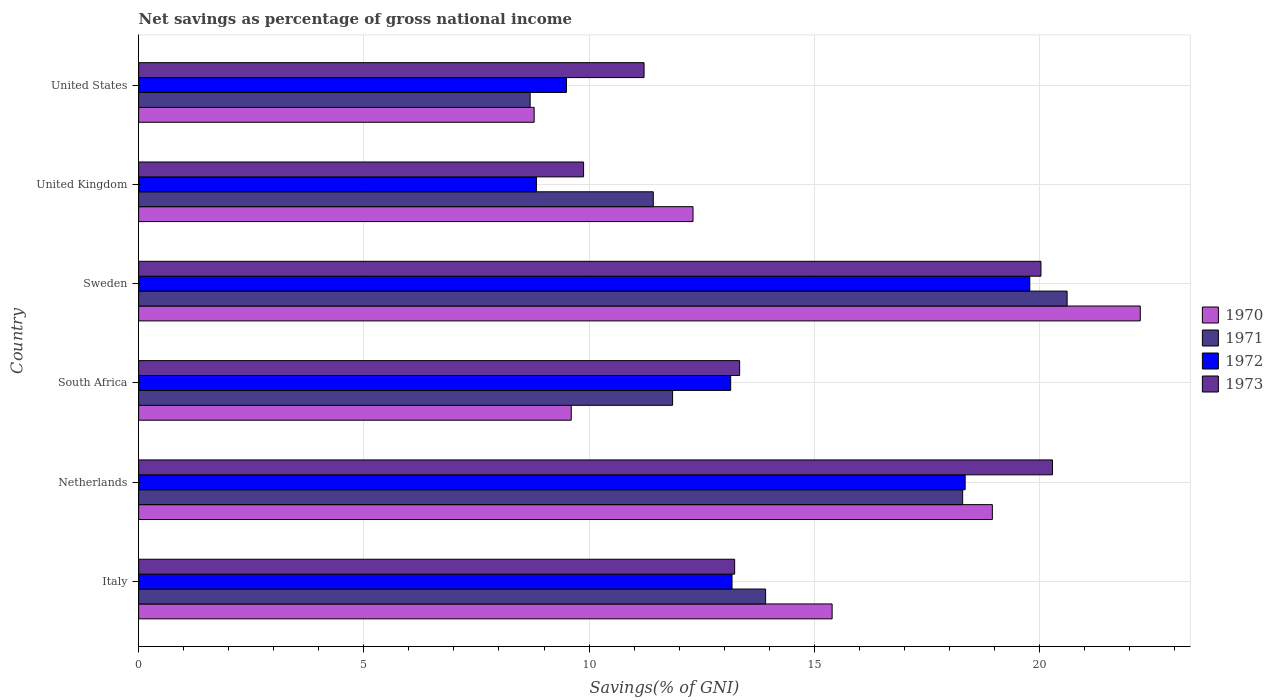How many groups of bars are there?
Your answer should be very brief. 6. Are the number of bars per tick equal to the number of legend labels?
Ensure brevity in your answer.  Yes. Are the number of bars on each tick of the Y-axis equal?
Make the answer very short. Yes. How many bars are there on the 3rd tick from the bottom?
Make the answer very short. 4. What is the total savings in 1970 in Italy?
Offer a terse response. 15.4. Across all countries, what is the maximum total savings in 1972?
Offer a terse response. 19.78. Across all countries, what is the minimum total savings in 1973?
Your answer should be compact. 9.88. In which country was the total savings in 1971 minimum?
Ensure brevity in your answer.  United States. What is the total total savings in 1973 in the graph?
Provide a short and direct response. 87.99. What is the difference between the total savings in 1970 in United Kingdom and that in United States?
Offer a very short reply. 3.53. What is the difference between the total savings in 1971 in Sweden and the total savings in 1973 in Netherlands?
Keep it short and to the point. 0.33. What is the average total savings in 1973 per country?
Offer a very short reply. 14.67. What is the difference between the total savings in 1971 and total savings in 1970 in United Kingdom?
Your answer should be very brief. -0.88. In how many countries, is the total savings in 1970 greater than 7 %?
Your response must be concise. 6. What is the ratio of the total savings in 1973 in Italy to that in Sweden?
Offer a very short reply. 0.66. What is the difference between the highest and the second highest total savings in 1971?
Your response must be concise. 2.32. What is the difference between the highest and the lowest total savings in 1970?
Offer a terse response. 13.46. Is the sum of the total savings in 1970 in Italy and United Kingdom greater than the maximum total savings in 1972 across all countries?
Offer a very short reply. Yes. Is it the case that in every country, the sum of the total savings in 1971 and total savings in 1970 is greater than the sum of total savings in 1972 and total savings in 1973?
Your answer should be very brief. No. What does the 3rd bar from the top in United Kingdom represents?
Keep it short and to the point. 1971. What does the 1st bar from the bottom in South Africa represents?
Keep it short and to the point. 1970. How many bars are there?
Keep it short and to the point. 24. What is the difference between two consecutive major ticks on the X-axis?
Provide a succinct answer. 5. Does the graph contain grids?
Keep it short and to the point. Yes. Where does the legend appear in the graph?
Your response must be concise. Center right. How many legend labels are there?
Provide a succinct answer. 4. How are the legend labels stacked?
Make the answer very short. Vertical. What is the title of the graph?
Make the answer very short. Net savings as percentage of gross national income. Does "2004" appear as one of the legend labels in the graph?
Keep it short and to the point. No. What is the label or title of the X-axis?
Provide a succinct answer. Savings(% of GNI). What is the Savings(% of GNI) of 1970 in Italy?
Your answer should be very brief. 15.4. What is the Savings(% of GNI) in 1971 in Italy?
Provide a succinct answer. 13.92. What is the Savings(% of GNI) in 1972 in Italy?
Make the answer very short. 13.17. What is the Savings(% of GNI) of 1973 in Italy?
Provide a succinct answer. 13.23. What is the Savings(% of GNI) in 1970 in Netherlands?
Your answer should be very brief. 18.95. What is the Savings(% of GNI) of 1971 in Netherlands?
Keep it short and to the point. 18.29. What is the Savings(% of GNI) in 1972 in Netherlands?
Your answer should be very brief. 18.35. What is the Savings(% of GNI) in 1973 in Netherlands?
Ensure brevity in your answer.  20.29. What is the Savings(% of GNI) in 1970 in South Africa?
Offer a terse response. 9.6. What is the Savings(% of GNI) in 1971 in South Africa?
Give a very brief answer. 11.85. What is the Savings(% of GNI) in 1972 in South Africa?
Provide a succinct answer. 13.14. What is the Savings(% of GNI) in 1973 in South Africa?
Provide a short and direct response. 13.34. What is the Savings(% of GNI) of 1970 in Sweden?
Provide a short and direct response. 22.24. What is the Savings(% of GNI) of 1971 in Sweden?
Offer a terse response. 20.61. What is the Savings(% of GNI) of 1972 in Sweden?
Your answer should be compact. 19.78. What is the Savings(% of GNI) in 1973 in Sweden?
Offer a terse response. 20.03. What is the Savings(% of GNI) of 1970 in United Kingdom?
Provide a short and direct response. 12.31. What is the Savings(% of GNI) in 1971 in United Kingdom?
Keep it short and to the point. 11.43. What is the Savings(% of GNI) in 1972 in United Kingdom?
Keep it short and to the point. 8.83. What is the Savings(% of GNI) of 1973 in United Kingdom?
Offer a very short reply. 9.88. What is the Savings(% of GNI) of 1970 in United States?
Provide a short and direct response. 8.78. What is the Savings(% of GNI) of 1971 in United States?
Offer a terse response. 8.69. What is the Savings(% of GNI) in 1972 in United States?
Your response must be concise. 9.5. What is the Savings(% of GNI) of 1973 in United States?
Provide a succinct answer. 11.22. Across all countries, what is the maximum Savings(% of GNI) of 1970?
Make the answer very short. 22.24. Across all countries, what is the maximum Savings(% of GNI) of 1971?
Provide a short and direct response. 20.61. Across all countries, what is the maximum Savings(% of GNI) in 1972?
Offer a very short reply. 19.78. Across all countries, what is the maximum Savings(% of GNI) in 1973?
Make the answer very short. 20.29. Across all countries, what is the minimum Savings(% of GNI) in 1970?
Your answer should be very brief. 8.78. Across all countries, what is the minimum Savings(% of GNI) of 1971?
Give a very brief answer. 8.69. Across all countries, what is the minimum Savings(% of GNI) in 1972?
Offer a terse response. 8.83. Across all countries, what is the minimum Savings(% of GNI) in 1973?
Ensure brevity in your answer.  9.88. What is the total Savings(% of GNI) of 1970 in the graph?
Your response must be concise. 87.28. What is the total Savings(% of GNI) of 1971 in the graph?
Offer a terse response. 84.8. What is the total Savings(% of GNI) of 1972 in the graph?
Give a very brief answer. 82.78. What is the total Savings(% of GNI) in 1973 in the graph?
Provide a succinct answer. 87.99. What is the difference between the Savings(% of GNI) in 1970 in Italy and that in Netherlands?
Ensure brevity in your answer.  -3.56. What is the difference between the Savings(% of GNI) in 1971 in Italy and that in Netherlands?
Provide a short and direct response. -4.37. What is the difference between the Savings(% of GNI) in 1972 in Italy and that in Netherlands?
Keep it short and to the point. -5.18. What is the difference between the Savings(% of GNI) of 1973 in Italy and that in Netherlands?
Keep it short and to the point. -7.06. What is the difference between the Savings(% of GNI) in 1970 in Italy and that in South Africa?
Your answer should be very brief. 5.79. What is the difference between the Savings(% of GNI) of 1971 in Italy and that in South Africa?
Make the answer very short. 2.07. What is the difference between the Savings(% of GNI) of 1972 in Italy and that in South Africa?
Give a very brief answer. 0.03. What is the difference between the Savings(% of GNI) in 1973 in Italy and that in South Africa?
Provide a succinct answer. -0.11. What is the difference between the Savings(% of GNI) in 1970 in Italy and that in Sweden?
Provide a short and direct response. -6.84. What is the difference between the Savings(% of GNI) of 1971 in Italy and that in Sweden?
Your response must be concise. -6.69. What is the difference between the Savings(% of GNI) of 1972 in Italy and that in Sweden?
Make the answer very short. -6.61. What is the difference between the Savings(% of GNI) of 1973 in Italy and that in Sweden?
Provide a succinct answer. -6.8. What is the difference between the Savings(% of GNI) of 1970 in Italy and that in United Kingdom?
Offer a very short reply. 3.09. What is the difference between the Savings(% of GNI) in 1971 in Italy and that in United Kingdom?
Offer a very short reply. 2.49. What is the difference between the Savings(% of GNI) of 1972 in Italy and that in United Kingdom?
Provide a short and direct response. 4.34. What is the difference between the Savings(% of GNI) in 1973 in Italy and that in United Kingdom?
Your answer should be very brief. 3.35. What is the difference between the Savings(% of GNI) of 1970 in Italy and that in United States?
Make the answer very short. 6.62. What is the difference between the Savings(% of GNI) of 1971 in Italy and that in United States?
Offer a very short reply. 5.23. What is the difference between the Savings(% of GNI) of 1972 in Italy and that in United States?
Provide a succinct answer. 3.68. What is the difference between the Savings(% of GNI) of 1973 in Italy and that in United States?
Keep it short and to the point. 2.01. What is the difference between the Savings(% of GNI) in 1970 in Netherlands and that in South Africa?
Make the answer very short. 9.35. What is the difference between the Savings(% of GNI) of 1971 in Netherlands and that in South Africa?
Offer a very short reply. 6.44. What is the difference between the Savings(% of GNI) in 1972 in Netherlands and that in South Africa?
Make the answer very short. 5.21. What is the difference between the Savings(% of GNI) of 1973 in Netherlands and that in South Africa?
Provide a succinct answer. 6.95. What is the difference between the Savings(% of GNI) in 1970 in Netherlands and that in Sweden?
Offer a terse response. -3.28. What is the difference between the Savings(% of GNI) in 1971 in Netherlands and that in Sweden?
Offer a very short reply. -2.32. What is the difference between the Savings(% of GNI) in 1972 in Netherlands and that in Sweden?
Offer a very short reply. -1.43. What is the difference between the Savings(% of GNI) in 1973 in Netherlands and that in Sweden?
Keep it short and to the point. 0.26. What is the difference between the Savings(% of GNI) of 1970 in Netherlands and that in United Kingdom?
Offer a terse response. 6.65. What is the difference between the Savings(% of GNI) in 1971 in Netherlands and that in United Kingdom?
Give a very brief answer. 6.87. What is the difference between the Savings(% of GNI) in 1972 in Netherlands and that in United Kingdom?
Give a very brief answer. 9.52. What is the difference between the Savings(% of GNI) of 1973 in Netherlands and that in United Kingdom?
Provide a short and direct response. 10.41. What is the difference between the Savings(% of GNI) in 1970 in Netherlands and that in United States?
Make the answer very short. 10.17. What is the difference between the Savings(% of GNI) of 1971 in Netherlands and that in United States?
Your answer should be very brief. 9.6. What is the difference between the Savings(% of GNI) in 1972 in Netherlands and that in United States?
Offer a terse response. 8.85. What is the difference between the Savings(% of GNI) of 1973 in Netherlands and that in United States?
Provide a short and direct response. 9.07. What is the difference between the Savings(% of GNI) in 1970 in South Africa and that in Sweden?
Provide a short and direct response. -12.63. What is the difference between the Savings(% of GNI) of 1971 in South Africa and that in Sweden?
Your answer should be very brief. -8.76. What is the difference between the Savings(% of GNI) of 1972 in South Africa and that in Sweden?
Make the answer very short. -6.64. What is the difference between the Savings(% of GNI) of 1973 in South Africa and that in Sweden?
Your response must be concise. -6.69. What is the difference between the Savings(% of GNI) in 1970 in South Africa and that in United Kingdom?
Ensure brevity in your answer.  -2.7. What is the difference between the Savings(% of GNI) of 1971 in South Africa and that in United Kingdom?
Your answer should be very brief. 0.43. What is the difference between the Savings(% of GNI) in 1972 in South Africa and that in United Kingdom?
Ensure brevity in your answer.  4.31. What is the difference between the Savings(% of GNI) of 1973 in South Africa and that in United Kingdom?
Offer a very short reply. 3.46. What is the difference between the Savings(% of GNI) of 1970 in South Africa and that in United States?
Your answer should be compact. 0.82. What is the difference between the Savings(% of GNI) of 1971 in South Africa and that in United States?
Provide a short and direct response. 3.16. What is the difference between the Savings(% of GNI) in 1972 in South Africa and that in United States?
Make the answer very short. 3.65. What is the difference between the Savings(% of GNI) of 1973 in South Africa and that in United States?
Your response must be concise. 2.12. What is the difference between the Savings(% of GNI) of 1970 in Sweden and that in United Kingdom?
Offer a very short reply. 9.93. What is the difference between the Savings(% of GNI) in 1971 in Sweden and that in United Kingdom?
Give a very brief answer. 9.19. What is the difference between the Savings(% of GNI) in 1972 in Sweden and that in United Kingdom?
Your answer should be very brief. 10.95. What is the difference between the Savings(% of GNI) of 1973 in Sweden and that in United Kingdom?
Offer a terse response. 10.15. What is the difference between the Savings(% of GNI) in 1970 in Sweden and that in United States?
Offer a terse response. 13.46. What is the difference between the Savings(% of GNI) in 1971 in Sweden and that in United States?
Keep it short and to the point. 11.92. What is the difference between the Savings(% of GNI) in 1972 in Sweden and that in United States?
Ensure brevity in your answer.  10.29. What is the difference between the Savings(% of GNI) of 1973 in Sweden and that in United States?
Ensure brevity in your answer.  8.81. What is the difference between the Savings(% of GNI) of 1970 in United Kingdom and that in United States?
Your answer should be compact. 3.53. What is the difference between the Savings(% of GNI) in 1971 in United Kingdom and that in United States?
Provide a short and direct response. 2.73. What is the difference between the Savings(% of GNI) of 1972 in United Kingdom and that in United States?
Offer a terse response. -0.67. What is the difference between the Savings(% of GNI) of 1973 in United Kingdom and that in United States?
Provide a short and direct response. -1.34. What is the difference between the Savings(% of GNI) of 1970 in Italy and the Savings(% of GNI) of 1971 in Netherlands?
Offer a terse response. -2.9. What is the difference between the Savings(% of GNI) in 1970 in Italy and the Savings(% of GNI) in 1972 in Netherlands?
Offer a terse response. -2.95. What is the difference between the Savings(% of GNI) of 1970 in Italy and the Savings(% of GNI) of 1973 in Netherlands?
Ensure brevity in your answer.  -4.89. What is the difference between the Savings(% of GNI) in 1971 in Italy and the Savings(% of GNI) in 1972 in Netherlands?
Keep it short and to the point. -4.43. What is the difference between the Savings(% of GNI) of 1971 in Italy and the Savings(% of GNI) of 1973 in Netherlands?
Your answer should be compact. -6.37. What is the difference between the Savings(% of GNI) of 1972 in Italy and the Savings(% of GNI) of 1973 in Netherlands?
Provide a short and direct response. -7.11. What is the difference between the Savings(% of GNI) of 1970 in Italy and the Savings(% of GNI) of 1971 in South Africa?
Offer a terse response. 3.54. What is the difference between the Savings(% of GNI) of 1970 in Italy and the Savings(% of GNI) of 1972 in South Africa?
Your answer should be very brief. 2.25. What is the difference between the Savings(% of GNI) of 1970 in Italy and the Savings(% of GNI) of 1973 in South Africa?
Offer a very short reply. 2.05. What is the difference between the Savings(% of GNI) in 1971 in Italy and the Savings(% of GNI) in 1972 in South Africa?
Ensure brevity in your answer.  0.78. What is the difference between the Savings(% of GNI) of 1971 in Italy and the Savings(% of GNI) of 1973 in South Africa?
Your answer should be compact. 0.58. What is the difference between the Savings(% of GNI) of 1972 in Italy and the Savings(% of GNI) of 1973 in South Africa?
Your answer should be very brief. -0.17. What is the difference between the Savings(% of GNI) of 1970 in Italy and the Savings(% of GNI) of 1971 in Sweden?
Your response must be concise. -5.22. What is the difference between the Savings(% of GNI) of 1970 in Italy and the Savings(% of GNI) of 1972 in Sweden?
Offer a terse response. -4.39. What is the difference between the Savings(% of GNI) in 1970 in Italy and the Savings(% of GNI) in 1973 in Sweden?
Your answer should be very brief. -4.64. What is the difference between the Savings(% of GNI) in 1971 in Italy and the Savings(% of GNI) in 1972 in Sweden?
Provide a succinct answer. -5.86. What is the difference between the Savings(% of GNI) in 1971 in Italy and the Savings(% of GNI) in 1973 in Sweden?
Keep it short and to the point. -6.11. What is the difference between the Savings(% of GNI) in 1972 in Italy and the Savings(% of GNI) in 1973 in Sweden?
Make the answer very short. -6.86. What is the difference between the Savings(% of GNI) of 1970 in Italy and the Savings(% of GNI) of 1971 in United Kingdom?
Offer a terse response. 3.97. What is the difference between the Savings(% of GNI) of 1970 in Italy and the Savings(% of GNI) of 1972 in United Kingdom?
Offer a very short reply. 6.56. What is the difference between the Savings(% of GNI) of 1970 in Italy and the Savings(% of GNI) of 1973 in United Kingdom?
Make the answer very short. 5.52. What is the difference between the Savings(% of GNI) in 1971 in Italy and the Savings(% of GNI) in 1972 in United Kingdom?
Keep it short and to the point. 5.09. What is the difference between the Savings(% of GNI) of 1971 in Italy and the Savings(% of GNI) of 1973 in United Kingdom?
Offer a very short reply. 4.04. What is the difference between the Savings(% of GNI) of 1972 in Italy and the Savings(% of GNI) of 1973 in United Kingdom?
Offer a terse response. 3.3. What is the difference between the Savings(% of GNI) of 1970 in Italy and the Savings(% of GNI) of 1971 in United States?
Your response must be concise. 6.7. What is the difference between the Savings(% of GNI) of 1970 in Italy and the Savings(% of GNI) of 1972 in United States?
Your answer should be very brief. 5.9. What is the difference between the Savings(% of GNI) of 1970 in Italy and the Savings(% of GNI) of 1973 in United States?
Provide a short and direct response. 4.17. What is the difference between the Savings(% of GNI) of 1971 in Italy and the Savings(% of GNI) of 1972 in United States?
Keep it short and to the point. 4.42. What is the difference between the Savings(% of GNI) in 1971 in Italy and the Savings(% of GNI) in 1973 in United States?
Offer a very short reply. 2.7. What is the difference between the Savings(% of GNI) in 1972 in Italy and the Savings(% of GNI) in 1973 in United States?
Offer a terse response. 1.95. What is the difference between the Savings(% of GNI) in 1970 in Netherlands and the Savings(% of GNI) in 1971 in South Africa?
Offer a very short reply. 7.1. What is the difference between the Savings(% of GNI) of 1970 in Netherlands and the Savings(% of GNI) of 1972 in South Africa?
Give a very brief answer. 5.81. What is the difference between the Savings(% of GNI) of 1970 in Netherlands and the Savings(% of GNI) of 1973 in South Africa?
Ensure brevity in your answer.  5.61. What is the difference between the Savings(% of GNI) of 1971 in Netherlands and the Savings(% of GNI) of 1972 in South Africa?
Keep it short and to the point. 5.15. What is the difference between the Savings(% of GNI) of 1971 in Netherlands and the Savings(% of GNI) of 1973 in South Africa?
Ensure brevity in your answer.  4.95. What is the difference between the Savings(% of GNI) in 1972 in Netherlands and the Savings(% of GNI) in 1973 in South Africa?
Your answer should be compact. 5.01. What is the difference between the Savings(% of GNI) of 1970 in Netherlands and the Savings(% of GNI) of 1971 in Sweden?
Make the answer very short. -1.66. What is the difference between the Savings(% of GNI) in 1970 in Netherlands and the Savings(% of GNI) in 1972 in Sweden?
Offer a terse response. -0.83. What is the difference between the Savings(% of GNI) of 1970 in Netherlands and the Savings(% of GNI) of 1973 in Sweden?
Your answer should be very brief. -1.08. What is the difference between the Savings(% of GNI) in 1971 in Netherlands and the Savings(% of GNI) in 1972 in Sweden?
Give a very brief answer. -1.49. What is the difference between the Savings(% of GNI) in 1971 in Netherlands and the Savings(% of GNI) in 1973 in Sweden?
Offer a terse response. -1.74. What is the difference between the Savings(% of GNI) in 1972 in Netherlands and the Savings(% of GNI) in 1973 in Sweden?
Provide a short and direct response. -1.68. What is the difference between the Savings(% of GNI) of 1970 in Netherlands and the Savings(% of GNI) of 1971 in United Kingdom?
Provide a succinct answer. 7.53. What is the difference between the Savings(% of GNI) of 1970 in Netherlands and the Savings(% of GNI) of 1972 in United Kingdom?
Your answer should be compact. 10.12. What is the difference between the Savings(% of GNI) in 1970 in Netherlands and the Savings(% of GNI) in 1973 in United Kingdom?
Ensure brevity in your answer.  9.07. What is the difference between the Savings(% of GNI) of 1971 in Netherlands and the Savings(% of GNI) of 1972 in United Kingdom?
Your answer should be very brief. 9.46. What is the difference between the Savings(% of GNI) in 1971 in Netherlands and the Savings(% of GNI) in 1973 in United Kingdom?
Your response must be concise. 8.42. What is the difference between the Savings(% of GNI) in 1972 in Netherlands and the Savings(% of GNI) in 1973 in United Kingdom?
Offer a very short reply. 8.47. What is the difference between the Savings(% of GNI) of 1970 in Netherlands and the Savings(% of GNI) of 1971 in United States?
Your answer should be very brief. 10.26. What is the difference between the Savings(% of GNI) of 1970 in Netherlands and the Savings(% of GNI) of 1972 in United States?
Offer a very short reply. 9.46. What is the difference between the Savings(% of GNI) of 1970 in Netherlands and the Savings(% of GNI) of 1973 in United States?
Make the answer very short. 7.73. What is the difference between the Savings(% of GNI) in 1971 in Netherlands and the Savings(% of GNI) in 1972 in United States?
Give a very brief answer. 8.8. What is the difference between the Savings(% of GNI) of 1971 in Netherlands and the Savings(% of GNI) of 1973 in United States?
Your response must be concise. 7.07. What is the difference between the Savings(% of GNI) in 1972 in Netherlands and the Savings(% of GNI) in 1973 in United States?
Make the answer very short. 7.13. What is the difference between the Savings(% of GNI) of 1970 in South Africa and the Savings(% of GNI) of 1971 in Sweden?
Keep it short and to the point. -11.01. What is the difference between the Savings(% of GNI) of 1970 in South Africa and the Savings(% of GNI) of 1972 in Sweden?
Make the answer very short. -10.18. What is the difference between the Savings(% of GNI) in 1970 in South Africa and the Savings(% of GNI) in 1973 in Sweden?
Your answer should be compact. -10.43. What is the difference between the Savings(% of GNI) in 1971 in South Africa and the Savings(% of GNI) in 1972 in Sweden?
Offer a terse response. -7.93. What is the difference between the Savings(% of GNI) of 1971 in South Africa and the Savings(% of GNI) of 1973 in Sweden?
Provide a short and direct response. -8.18. What is the difference between the Savings(% of GNI) of 1972 in South Africa and the Savings(% of GNI) of 1973 in Sweden?
Ensure brevity in your answer.  -6.89. What is the difference between the Savings(% of GNI) of 1970 in South Africa and the Savings(% of GNI) of 1971 in United Kingdom?
Offer a very short reply. -1.82. What is the difference between the Savings(% of GNI) in 1970 in South Africa and the Savings(% of GNI) in 1972 in United Kingdom?
Provide a short and direct response. 0.77. What is the difference between the Savings(% of GNI) of 1970 in South Africa and the Savings(% of GNI) of 1973 in United Kingdom?
Give a very brief answer. -0.27. What is the difference between the Savings(% of GNI) of 1971 in South Africa and the Savings(% of GNI) of 1972 in United Kingdom?
Your response must be concise. 3.02. What is the difference between the Savings(% of GNI) of 1971 in South Africa and the Savings(% of GNI) of 1973 in United Kingdom?
Provide a short and direct response. 1.98. What is the difference between the Savings(% of GNI) of 1972 in South Africa and the Savings(% of GNI) of 1973 in United Kingdom?
Provide a succinct answer. 3.27. What is the difference between the Savings(% of GNI) of 1970 in South Africa and the Savings(% of GNI) of 1971 in United States?
Provide a short and direct response. 0.91. What is the difference between the Savings(% of GNI) of 1970 in South Africa and the Savings(% of GNI) of 1972 in United States?
Provide a succinct answer. 0.11. What is the difference between the Savings(% of GNI) of 1970 in South Africa and the Savings(% of GNI) of 1973 in United States?
Offer a terse response. -1.62. What is the difference between the Savings(% of GNI) in 1971 in South Africa and the Savings(% of GNI) in 1972 in United States?
Make the answer very short. 2.36. What is the difference between the Savings(% of GNI) of 1971 in South Africa and the Savings(% of GNI) of 1973 in United States?
Your response must be concise. 0.63. What is the difference between the Savings(% of GNI) in 1972 in South Africa and the Savings(% of GNI) in 1973 in United States?
Your response must be concise. 1.92. What is the difference between the Savings(% of GNI) of 1970 in Sweden and the Savings(% of GNI) of 1971 in United Kingdom?
Keep it short and to the point. 10.81. What is the difference between the Savings(% of GNI) of 1970 in Sweden and the Savings(% of GNI) of 1972 in United Kingdom?
Provide a short and direct response. 13.41. What is the difference between the Savings(% of GNI) in 1970 in Sweden and the Savings(% of GNI) in 1973 in United Kingdom?
Give a very brief answer. 12.36. What is the difference between the Savings(% of GNI) of 1971 in Sweden and the Savings(% of GNI) of 1972 in United Kingdom?
Ensure brevity in your answer.  11.78. What is the difference between the Savings(% of GNI) in 1971 in Sweden and the Savings(% of GNI) in 1973 in United Kingdom?
Keep it short and to the point. 10.73. What is the difference between the Savings(% of GNI) of 1972 in Sweden and the Savings(% of GNI) of 1973 in United Kingdom?
Your answer should be compact. 9.91. What is the difference between the Savings(% of GNI) of 1970 in Sweden and the Savings(% of GNI) of 1971 in United States?
Keep it short and to the point. 13.54. What is the difference between the Savings(% of GNI) of 1970 in Sweden and the Savings(% of GNI) of 1972 in United States?
Give a very brief answer. 12.74. What is the difference between the Savings(% of GNI) of 1970 in Sweden and the Savings(% of GNI) of 1973 in United States?
Provide a short and direct response. 11.02. What is the difference between the Savings(% of GNI) in 1971 in Sweden and the Savings(% of GNI) in 1972 in United States?
Your answer should be compact. 11.12. What is the difference between the Savings(% of GNI) of 1971 in Sweden and the Savings(% of GNI) of 1973 in United States?
Your response must be concise. 9.39. What is the difference between the Savings(% of GNI) in 1972 in Sweden and the Savings(% of GNI) in 1973 in United States?
Your answer should be compact. 8.56. What is the difference between the Savings(% of GNI) of 1970 in United Kingdom and the Savings(% of GNI) of 1971 in United States?
Your answer should be compact. 3.62. What is the difference between the Savings(% of GNI) in 1970 in United Kingdom and the Savings(% of GNI) in 1972 in United States?
Offer a very short reply. 2.81. What is the difference between the Savings(% of GNI) in 1970 in United Kingdom and the Savings(% of GNI) in 1973 in United States?
Keep it short and to the point. 1.09. What is the difference between the Savings(% of GNI) of 1971 in United Kingdom and the Savings(% of GNI) of 1972 in United States?
Give a very brief answer. 1.93. What is the difference between the Savings(% of GNI) of 1971 in United Kingdom and the Savings(% of GNI) of 1973 in United States?
Provide a short and direct response. 0.2. What is the difference between the Savings(% of GNI) in 1972 in United Kingdom and the Savings(% of GNI) in 1973 in United States?
Ensure brevity in your answer.  -2.39. What is the average Savings(% of GNI) in 1970 per country?
Keep it short and to the point. 14.55. What is the average Savings(% of GNI) in 1971 per country?
Keep it short and to the point. 14.13. What is the average Savings(% of GNI) of 1972 per country?
Offer a terse response. 13.8. What is the average Savings(% of GNI) of 1973 per country?
Give a very brief answer. 14.67. What is the difference between the Savings(% of GNI) in 1970 and Savings(% of GNI) in 1971 in Italy?
Offer a very short reply. 1.48. What is the difference between the Savings(% of GNI) in 1970 and Savings(% of GNI) in 1972 in Italy?
Your response must be concise. 2.22. What is the difference between the Savings(% of GNI) in 1970 and Savings(% of GNI) in 1973 in Italy?
Offer a very short reply. 2.16. What is the difference between the Savings(% of GNI) in 1971 and Savings(% of GNI) in 1972 in Italy?
Provide a short and direct response. 0.75. What is the difference between the Savings(% of GNI) of 1971 and Savings(% of GNI) of 1973 in Italy?
Provide a succinct answer. 0.69. What is the difference between the Savings(% of GNI) of 1972 and Savings(% of GNI) of 1973 in Italy?
Make the answer very short. -0.06. What is the difference between the Savings(% of GNI) in 1970 and Savings(% of GNI) in 1971 in Netherlands?
Offer a terse response. 0.66. What is the difference between the Savings(% of GNI) in 1970 and Savings(% of GNI) in 1972 in Netherlands?
Make the answer very short. 0.6. What is the difference between the Savings(% of GNI) of 1970 and Savings(% of GNI) of 1973 in Netherlands?
Your answer should be very brief. -1.33. What is the difference between the Savings(% of GNI) in 1971 and Savings(% of GNI) in 1972 in Netherlands?
Offer a terse response. -0.06. What is the difference between the Savings(% of GNI) of 1971 and Savings(% of GNI) of 1973 in Netherlands?
Provide a short and direct response. -1.99. What is the difference between the Savings(% of GNI) in 1972 and Savings(% of GNI) in 1973 in Netherlands?
Your answer should be compact. -1.94. What is the difference between the Savings(% of GNI) in 1970 and Savings(% of GNI) in 1971 in South Africa?
Offer a very short reply. -2.25. What is the difference between the Savings(% of GNI) in 1970 and Savings(% of GNI) in 1972 in South Africa?
Give a very brief answer. -3.54. What is the difference between the Savings(% of GNI) of 1970 and Savings(% of GNI) of 1973 in South Africa?
Keep it short and to the point. -3.74. What is the difference between the Savings(% of GNI) in 1971 and Savings(% of GNI) in 1972 in South Africa?
Provide a short and direct response. -1.29. What is the difference between the Savings(% of GNI) of 1971 and Savings(% of GNI) of 1973 in South Africa?
Give a very brief answer. -1.49. What is the difference between the Savings(% of GNI) of 1972 and Savings(% of GNI) of 1973 in South Africa?
Provide a succinct answer. -0.2. What is the difference between the Savings(% of GNI) in 1970 and Savings(% of GNI) in 1971 in Sweden?
Your answer should be compact. 1.62. What is the difference between the Savings(% of GNI) of 1970 and Savings(% of GNI) of 1972 in Sweden?
Your answer should be compact. 2.45. What is the difference between the Savings(% of GNI) of 1970 and Savings(% of GNI) of 1973 in Sweden?
Your response must be concise. 2.21. What is the difference between the Savings(% of GNI) in 1971 and Savings(% of GNI) in 1972 in Sweden?
Offer a terse response. 0.83. What is the difference between the Savings(% of GNI) in 1971 and Savings(% of GNI) in 1973 in Sweden?
Offer a very short reply. 0.58. What is the difference between the Savings(% of GNI) of 1972 and Savings(% of GNI) of 1973 in Sweden?
Give a very brief answer. -0.25. What is the difference between the Savings(% of GNI) in 1970 and Savings(% of GNI) in 1971 in United Kingdom?
Provide a succinct answer. 0.88. What is the difference between the Savings(% of GNI) of 1970 and Savings(% of GNI) of 1972 in United Kingdom?
Your answer should be very brief. 3.48. What is the difference between the Savings(% of GNI) in 1970 and Savings(% of GNI) in 1973 in United Kingdom?
Keep it short and to the point. 2.43. What is the difference between the Savings(% of GNI) of 1971 and Savings(% of GNI) of 1972 in United Kingdom?
Your answer should be compact. 2.59. What is the difference between the Savings(% of GNI) in 1971 and Savings(% of GNI) in 1973 in United Kingdom?
Give a very brief answer. 1.55. What is the difference between the Savings(% of GNI) of 1972 and Savings(% of GNI) of 1973 in United Kingdom?
Your answer should be very brief. -1.05. What is the difference between the Savings(% of GNI) of 1970 and Savings(% of GNI) of 1971 in United States?
Your response must be concise. 0.09. What is the difference between the Savings(% of GNI) in 1970 and Savings(% of GNI) in 1972 in United States?
Keep it short and to the point. -0.72. What is the difference between the Savings(% of GNI) of 1970 and Savings(% of GNI) of 1973 in United States?
Your answer should be very brief. -2.44. What is the difference between the Savings(% of GNI) of 1971 and Savings(% of GNI) of 1972 in United States?
Give a very brief answer. -0.81. What is the difference between the Savings(% of GNI) in 1971 and Savings(% of GNI) in 1973 in United States?
Your response must be concise. -2.53. What is the difference between the Savings(% of GNI) in 1972 and Savings(% of GNI) in 1973 in United States?
Offer a terse response. -1.72. What is the ratio of the Savings(% of GNI) in 1970 in Italy to that in Netherlands?
Ensure brevity in your answer.  0.81. What is the ratio of the Savings(% of GNI) of 1971 in Italy to that in Netherlands?
Make the answer very short. 0.76. What is the ratio of the Savings(% of GNI) of 1972 in Italy to that in Netherlands?
Your response must be concise. 0.72. What is the ratio of the Savings(% of GNI) in 1973 in Italy to that in Netherlands?
Ensure brevity in your answer.  0.65. What is the ratio of the Savings(% of GNI) of 1970 in Italy to that in South Africa?
Offer a very short reply. 1.6. What is the ratio of the Savings(% of GNI) of 1971 in Italy to that in South Africa?
Ensure brevity in your answer.  1.17. What is the ratio of the Savings(% of GNI) in 1972 in Italy to that in South Africa?
Your response must be concise. 1. What is the ratio of the Savings(% of GNI) in 1970 in Italy to that in Sweden?
Provide a succinct answer. 0.69. What is the ratio of the Savings(% of GNI) in 1971 in Italy to that in Sweden?
Make the answer very short. 0.68. What is the ratio of the Savings(% of GNI) in 1972 in Italy to that in Sweden?
Provide a short and direct response. 0.67. What is the ratio of the Savings(% of GNI) in 1973 in Italy to that in Sweden?
Provide a succinct answer. 0.66. What is the ratio of the Savings(% of GNI) in 1970 in Italy to that in United Kingdom?
Make the answer very short. 1.25. What is the ratio of the Savings(% of GNI) in 1971 in Italy to that in United Kingdom?
Make the answer very short. 1.22. What is the ratio of the Savings(% of GNI) in 1972 in Italy to that in United Kingdom?
Provide a short and direct response. 1.49. What is the ratio of the Savings(% of GNI) of 1973 in Italy to that in United Kingdom?
Offer a very short reply. 1.34. What is the ratio of the Savings(% of GNI) of 1970 in Italy to that in United States?
Your response must be concise. 1.75. What is the ratio of the Savings(% of GNI) of 1971 in Italy to that in United States?
Your response must be concise. 1.6. What is the ratio of the Savings(% of GNI) in 1972 in Italy to that in United States?
Provide a short and direct response. 1.39. What is the ratio of the Savings(% of GNI) of 1973 in Italy to that in United States?
Your answer should be very brief. 1.18. What is the ratio of the Savings(% of GNI) of 1970 in Netherlands to that in South Africa?
Provide a succinct answer. 1.97. What is the ratio of the Savings(% of GNI) of 1971 in Netherlands to that in South Africa?
Offer a terse response. 1.54. What is the ratio of the Savings(% of GNI) of 1972 in Netherlands to that in South Africa?
Ensure brevity in your answer.  1.4. What is the ratio of the Savings(% of GNI) of 1973 in Netherlands to that in South Africa?
Ensure brevity in your answer.  1.52. What is the ratio of the Savings(% of GNI) of 1970 in Netherlands to that in Sweden?
Provide a short and direct response. 0.85. What is the ratio of the Savings(% of GNI) of 1971 in Netherlands to that in Sweden?
Ensure brevity in your answer.  0.89. What is the ratio of the Savings(% of GNI) of 1972 in Netherlands to that in Sweden?
Keep it short and to the point. 0.93. What is the ratio of the Savings(% of GNI) in 1973 in Netherlands to that in Sweden?
Your response must be concise. 1.01. What is the ratio of the Savings(% of GNI) of 1970 in Netherlands to that in United Kingdom?
Your response must be concise. 1.54. What is the ratio of the Savings(% of GNI) in 1971 in Netherlands to that in United Kingdom?
Give a very brief answer. 1.6. What is the ratio of the Savings(% of GNI) in 1972 in Netherlands to that in United Kingdom?
Offer a very short reply. 2.08. What is the ratio of the Savings(% of GNI) in 1973 in Netherlands to that in United Kingdom?
Provide a succinct answer. 2.05. What is the ratio of the Savings(% of GNI) in 1970 in Netherlands to that in United States?
Offer a very short reply. 2.16. What is the ratio of the Savings(% of GNI) of 1971 in Netherlands to that in United States?
Offer a very short reply. 2.1. What is the ratio of the Savings(% of GNI) of 1972 in Netherlands to that in United States?
Give a very brief answer. 1.93. What is the ratio of the Savings(% of GNI) in 1973 in Netherlands to that in United States?
Offer a very short reply. 1.81. What is the ratio of the Savings(% of GNI) in 1970 in South Africa to that in Sweden?
Ensure brevity in your answer.  0.43. What is the ratio of the Savings(% of GNI) of 1971 in South Africa to that in Sweden?
Ensure brevity in your answer.  0.58. What is the ratio of the Savings(% of GNI) in 1972 in South Africa to that in Sweden?
Make the answer very short. 0.66. What is the ratio of the Savings(% of GNI) in 1973 in South Africa to that in Sweden?
Your answer should be compact. 0.67. What is the ratio of the Savings(% of GNI) in 1970 in South Africa to that in United Kingdom?
Give a very brief answer. 0.78. What is the ratio of the Savings(% of GNI) of 1971 in South Africa to that in United Kingdom?
Your answer should be compact. 1.04. What is the ratio of the Savings(% of GNI) of 1972 in South Africa to that in United Kingdom?
Your answer should be very brief. 1.49. What is the ratio of the Savings(% of GNI) in 1973 in South Africa to that in United Kingdom?
Offer a terse response. 1.35. What is the ratio of the Savings(% of GNI) in 1970 in South Africa to that in United States?
Provide a short and direct response. 1.09. What is the ratio of the Savings(% of GNI) in 1971 in South Africa to that in United States?
Provide a succinct answer. 1.36. What is the ratio of the Savings(% of GNI) of 1972 in South Africa to that in United States?
Your response must be concise. 1.38. What is the ratio of the Savings(% of GNI) of 1973 in South Africa to that in United States?
Ensure brevity in your answer.  1.19. What is the ratio of the Savings(% of GNI) of 1970 in Sweden to that in United Kingdom?
Your answer should be very brief. 1.81. What is the ratio of the Savings(% of GNI) of 1971 in Sweden to that in United Kingdom?
Your answer should be compact. 1.8. What is the ratio of the Savings(% of GNI) in 1972 in Sweden to that in United Kingdom?
Your response must be concise. 2.24. What is the ratio of the Savings(% of GNI) of 1973 in Sweden to that in United Kingdom?
Offer a very short reply. 2.03. What is the ratio of the Savings(% of GNI) in 1970 in Sweden to that in United States?
Your response must be concise. 2.53. What is the ratio of the Savings(% of GNI) in 1971 in Sweden to that in United States?
Provide a short and direct response. 2.37. What is the ratio of the Savings(% of GNI) in 1972 in Sweden to that in United States?
Your response must be concise. 2.08. What is the ratio of the Savings(% of GNI) in 1973 in Sweden to that in United States?
Provide a succinct answer. 1.79. What is the ratio of the Savings(% of GNI) in 1970 in United Kingdom to that in United States?
Offer a terse response. 1.4. What is the ratio of the Savings(% of GNI) of 1971 in United Kingdom to that in United States?
Provide a succinct answer. 1.31. What is the ratio of the Savings(% of GNI) of 1972 in United Kingdom to that in United States?
Your answer should be very brief. 0.93. What is the ratio of the Savings(% of GNI) of 1973 in United Kingdom to that in United States?
Give a very brief answer. 0.88. What is the difference between the highest and the second highest Savings(% of GNI) in 1970?
Ensure brevity in your answer.  3.28. What is the difference between the highest and the second highest Savings(% of GNI) of 1971?
Make the answer very short. 2.32. What is the difference between the highest and the second highest Savings(% of GNI) in 1972?
Keep it short and to the point. 1.43. What is the difference between the highest and the second highest Savings(% of GNI) in 1973?
Ensure brevity in your answer.  0.26. What is the difference between the highest and the lowest Savings(% of GNI) in 1970?
Keep it short and to the point. 13.46. What is the difference between the highest and the lowest Savings(% of GNI) in 1971?
Provide a succinct answer. 11.92. What is the difference between the highest and the lowest Savings(% of GNI) in 1972?
Keep it short and to the point. 10.95. What is the difference between the highest and the lowest Savings(% of GNI) in 1973?
Give a very brief answer. 10.41. 